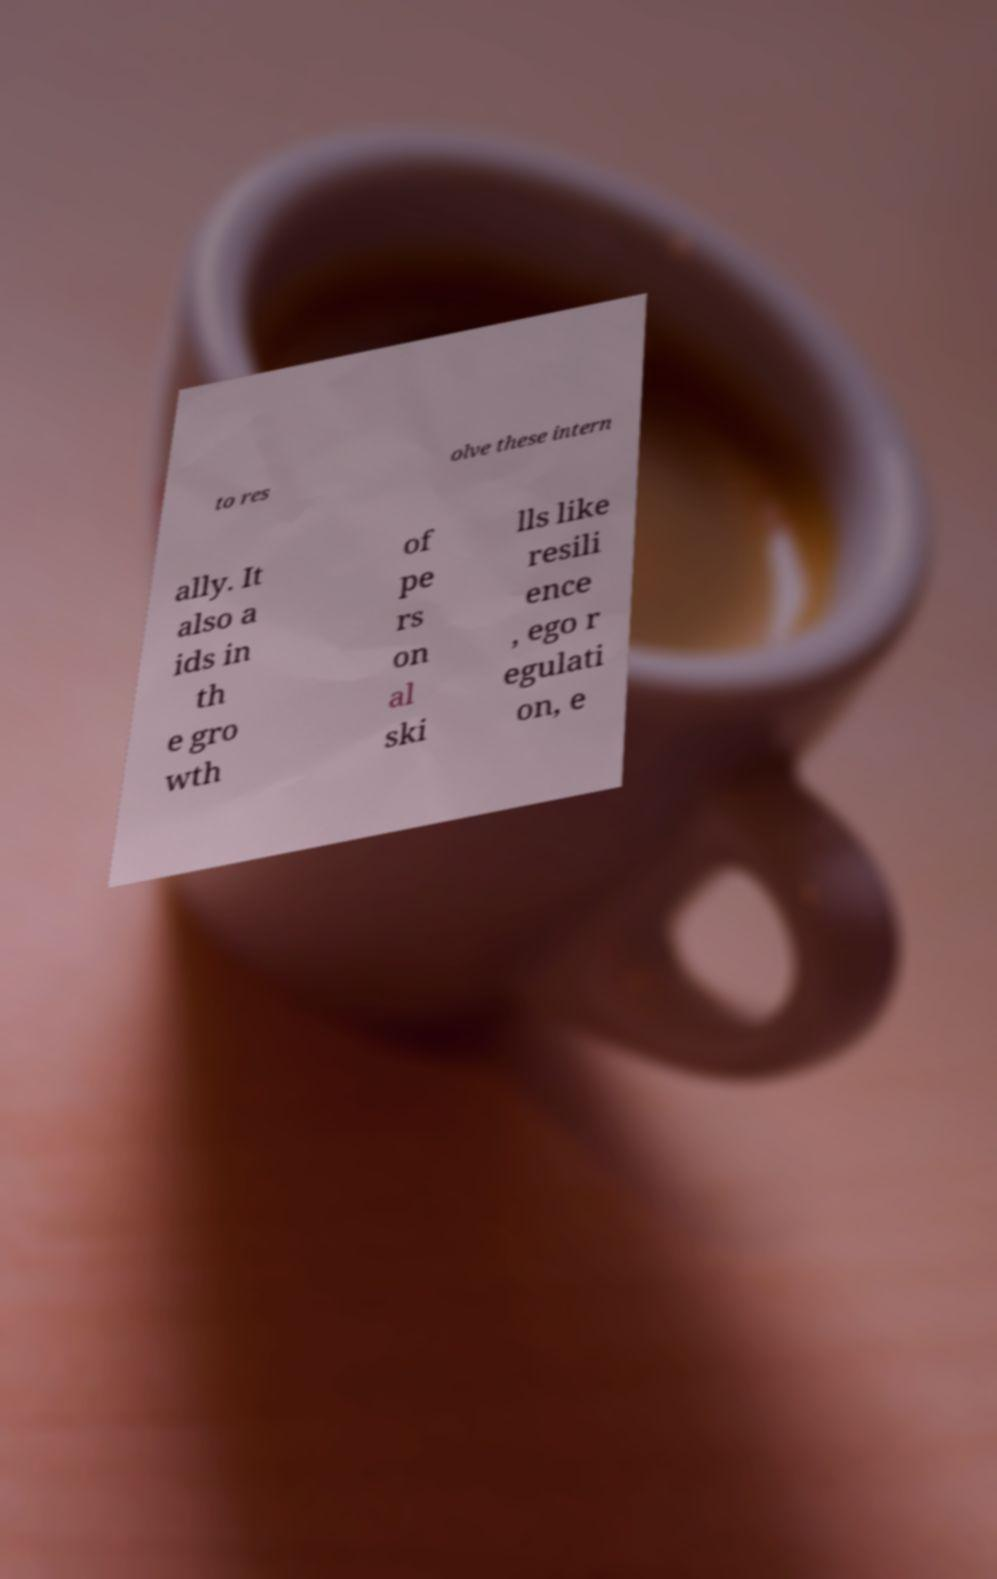What messages or text are displayed in this image? I need them in a readable, typed format. to res olve these intern ally. It also a ids in th e gro wth of pe rs on al ski lls like resili ence , ego r egulati on, e 